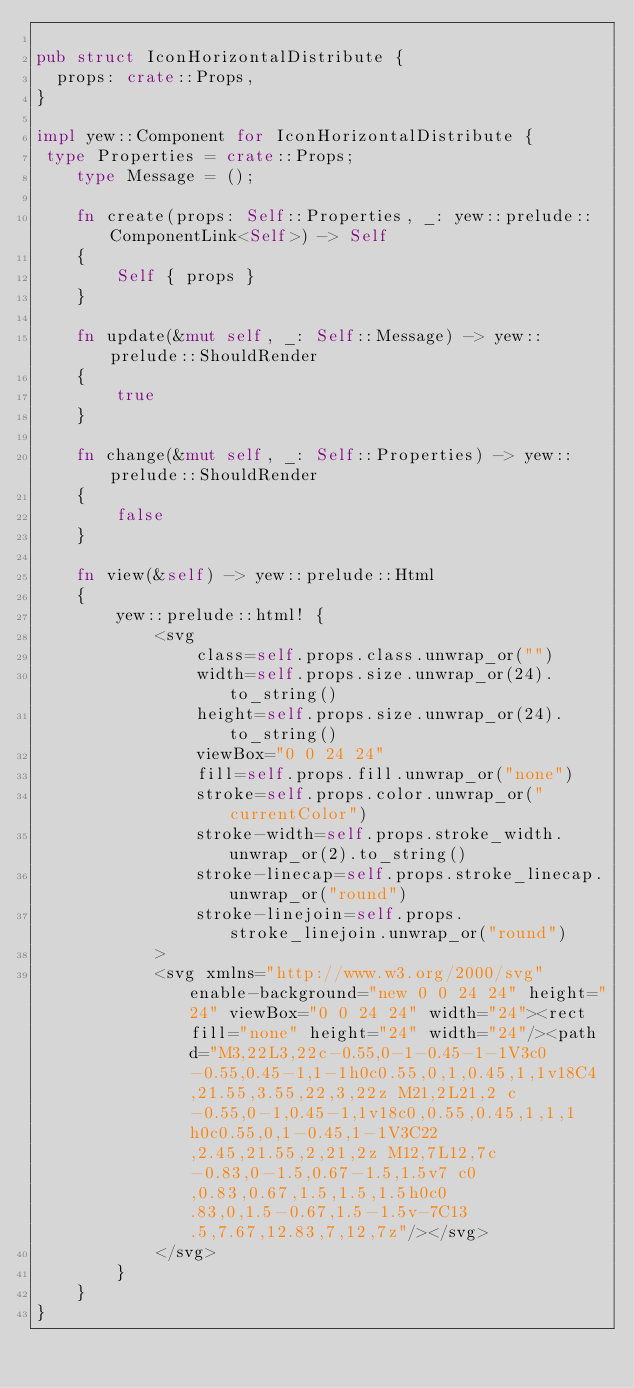<code> <loc_0><loc_0><loc_500><loc_500><_Rust_>
pub struct IconHorizontalDistribute {
  props: crate::Props,
}

impl yew::Component for IconHorizontalDistribute {
 type Properties = crate::Props;
    type Message = ();

    fn create(props: Self::Properties, _: yew::prelude::ComponentLink<Self>) -> Self
    {
        Self { props }
    }

    fn update(&mut self, _: Self::Message) -> yew::prelude::ShouldRender
    {
        true
    }

    fn change(&mut self, _: Self::Properties) -> yew::prelude::ShouldRender
    {
        false
    }

    fn view(&self) -> yew::prelude::Html
    {
        yew::prelude::html! {
            <svg
                class=self.props.class.unwrap_or("")
                width=self.props.size.unwrap_or(24).to_string()
                height=self.props.size.unwrap_or(24).to_string()
                viewBox="0 0 24 24"
                fill=self.props.fill.unwrap_or("none")
                stroke=self.props.color.unwrap_or("currentColor")
                stroke-width=self.props.stroke_width.unwrap_or(2).to_string()
                stroke-linecap=self.props.stroke_linecap.unwrap_or("round")
                stroke-linejoin=self.props.stroke_linejoin.unwrap_or("round")
            >
            <svg xmlns="http://www.w3.org/2000/svg" enable-background="new 0 0 24 24" height="24" viewBox="0 0 24 24" width="24"><rect fill="none" height="24" width="24"/><path d="M3,22L3,22c-0.55,0-1-0.45-1-1V3c0-0.55,0.45-1,1-1h0c0.55,0,1,0.45,1,1v18C4,21.55,3.55,22,3,22z M21,2L21,2 c-0.55,0-1,0.45-1,1v18c0,0.55,0.45,1,1,1h0c0.55,0,1-0.45,1-1V3C22,2.45,21.55,2,21,2z M12,7L12,7c-0.83,0-1.5,0.67-1.5,1.5v7 c0,0.83,0.67,1.5,1.5,1.5h0c0.83,0,1.5-0.67,1.5-1.5v-7C13.5,7.67,12.83,7,12,7z"/></svg>
            </svg>
        }
    }
}


</code> 